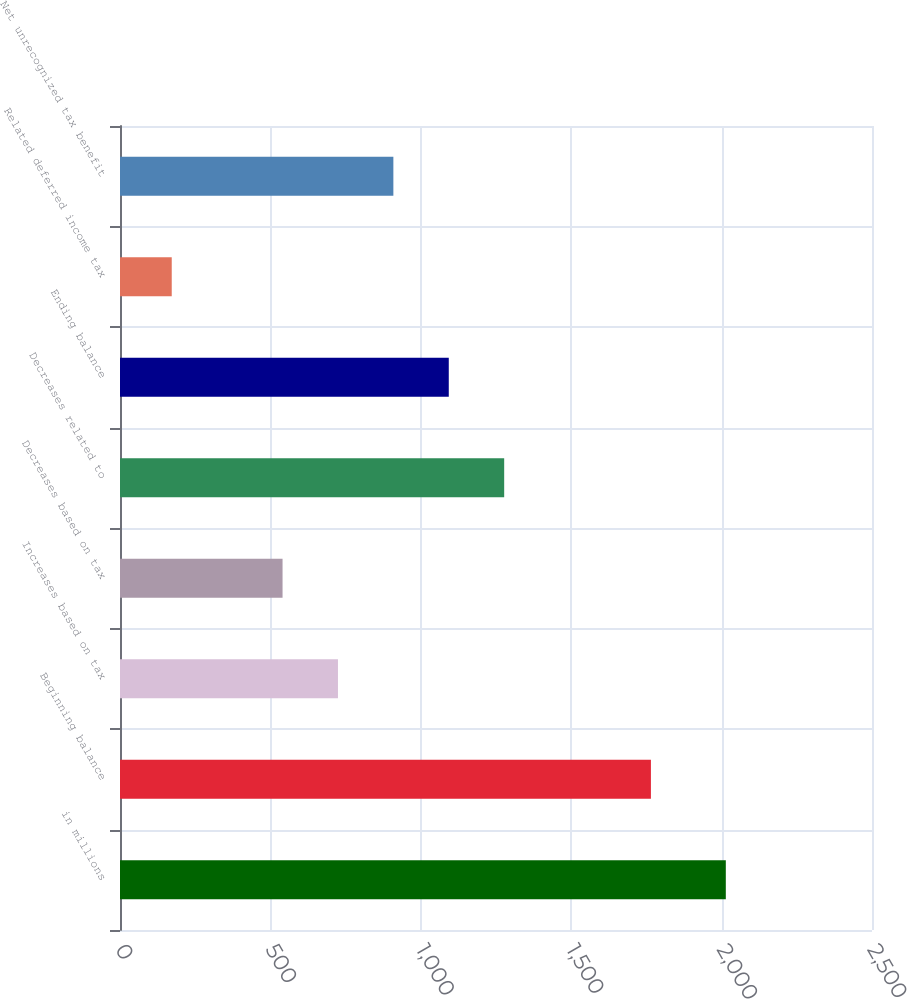<chart> <loc_0><loc_0><loc_500><loc_500><bar_chart><fcel>in millions<fcel>Beginning balance<fcel>Increases based on tax<fcel>Decreases based on tax<fcel>Decreases related to<fcel>Ending balance<fcel>Related deferred income tax<fcel>Net unrecognized tax benefit<nl><fcel>2014<fcel>1765<fcel>724.6<fcel>540.4<fcel>1277.2<fcel>1093<fcel>172<fcel>908.8<nl></chart> 